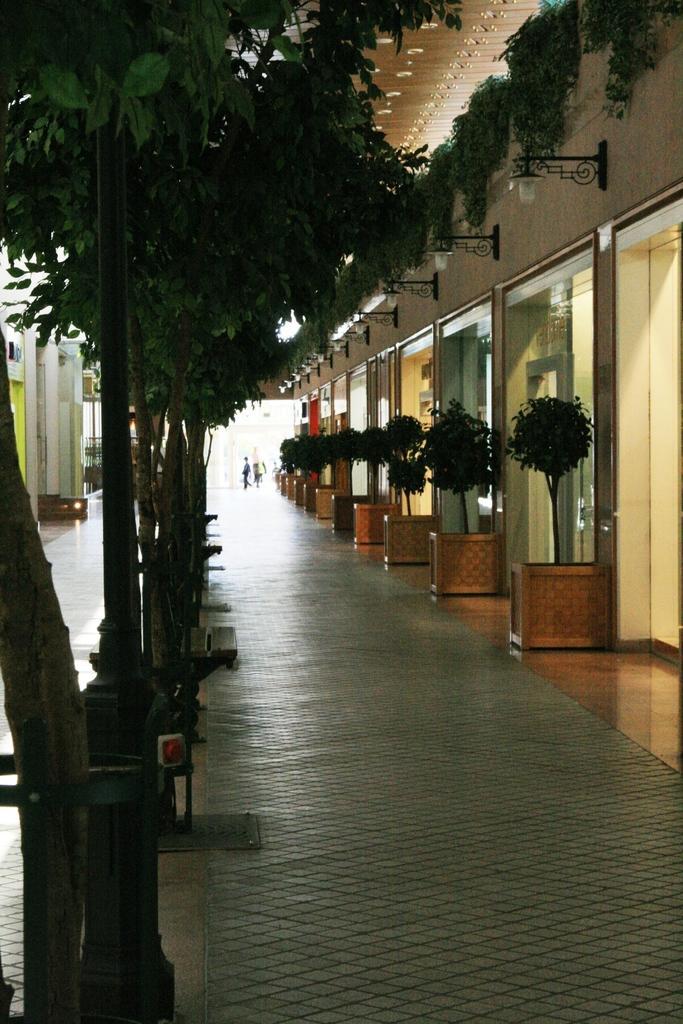How would you summarize this image in a sentence or two? In this image I can see on the left side there are trees, on the right side there are plants, glasses and lights. 